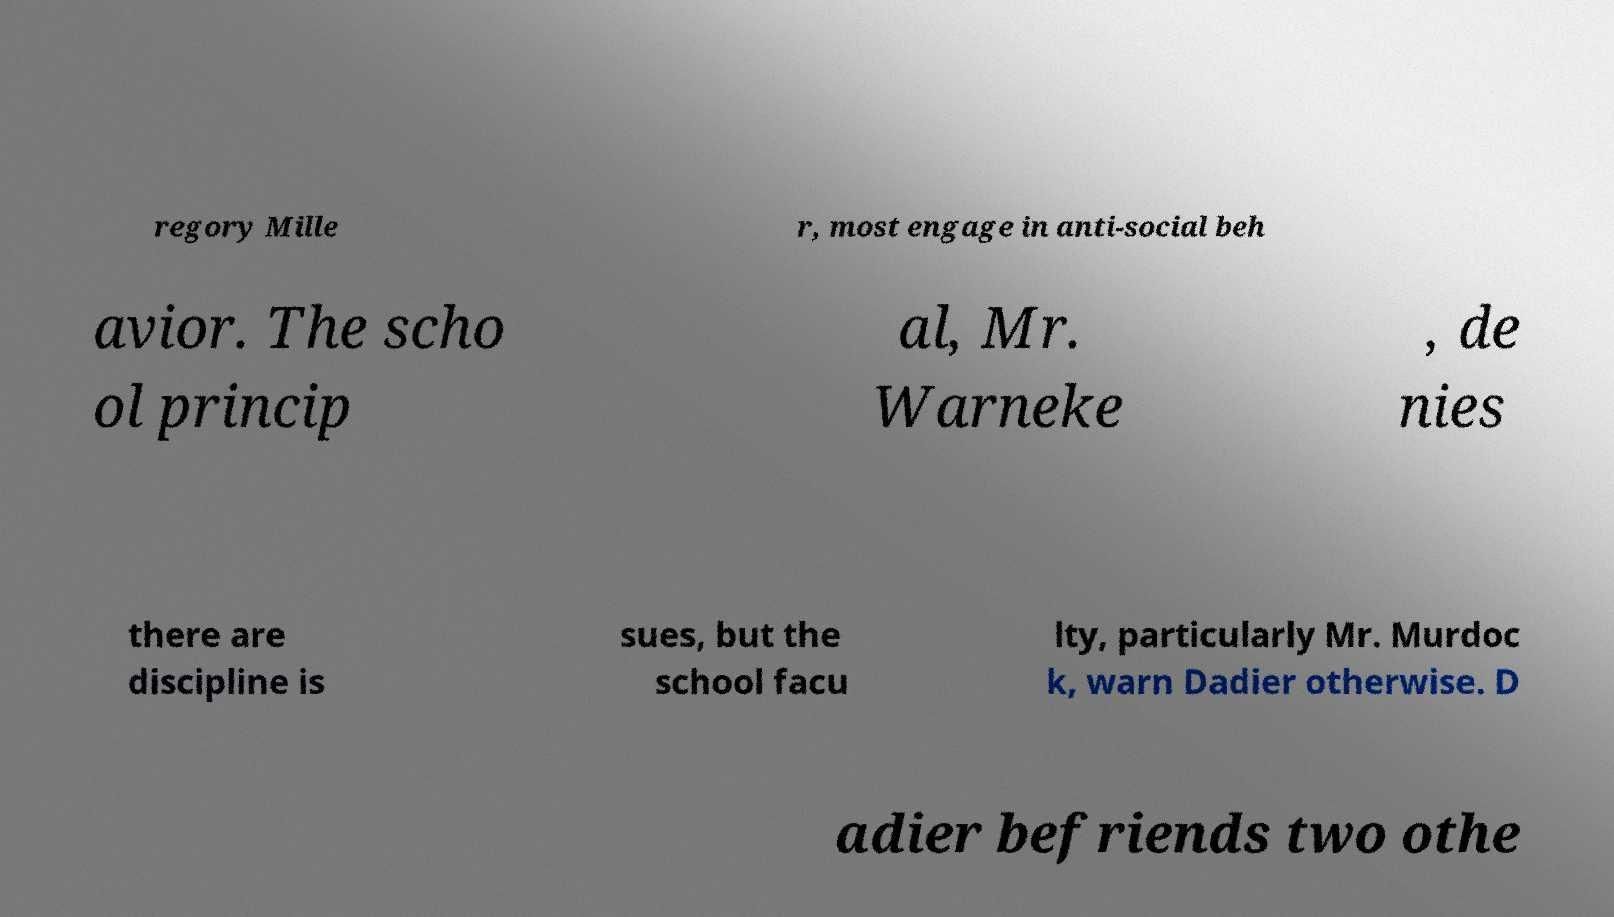I need the written content from this picture converted into text. Can you do that? regory Mille r, most engage in anti-social beh avior. The scho ol princip al, Mr. Warneke , de nies there are discipline is sues, but the school facu lty, particularly Mr. Murdoc k, warn Dadier otherwise. D adier befriends two othe 